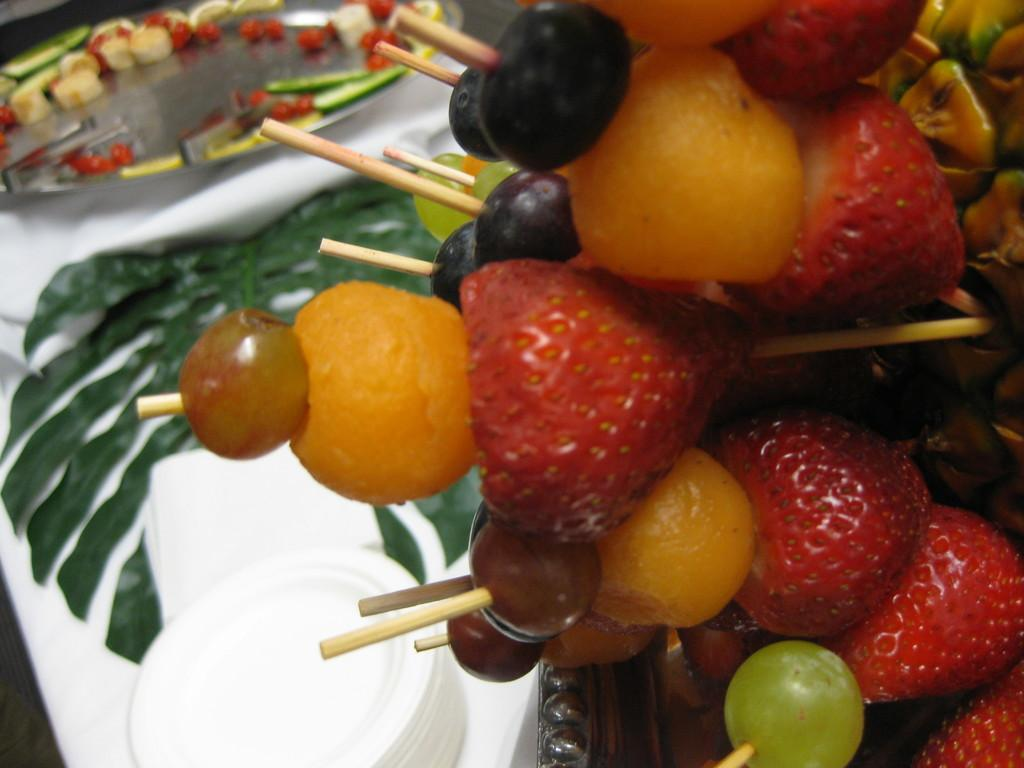What type of food can be seen in the image? There are fruits in the image. What objects are used in conjunction with the fruits? There are sticks in the image. What are the fruits placed on? There are plates in the image. What is the material covering the table or surface in the image? There is a cloth in the image. How are some of the fruits arranged in the image? Some fruits are on the plate. What can be observed about the background of the image? The background of the image is blurred. What expert is giving advice near the mailbox in the image? There is no expert or mailbox present in the image. What type of dog can be seen playing with the fruits in the image? There is no dog present in the image; it only features fruits, sticks, plates, a cloth, and a blurred background. 